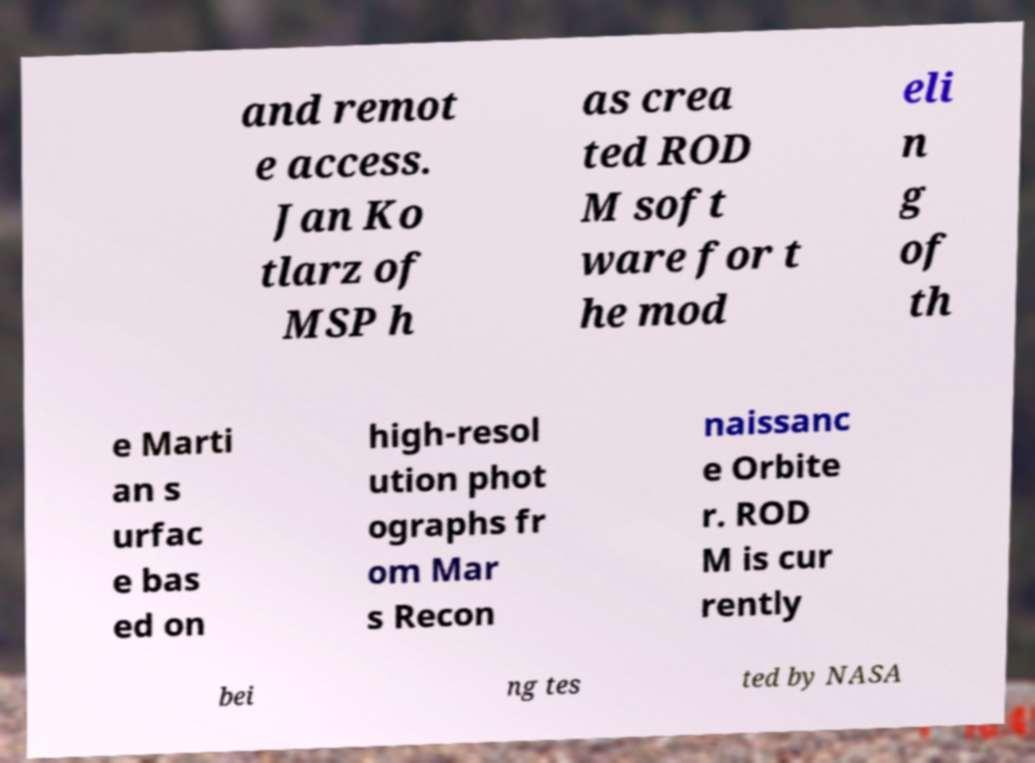There's text embedded in this image that I need extracted. Can you transcribe it verbatim? and remot e access. Jan Ko tlarz of MSP h as crea ted ROD M soft ware for t he mod eli n g of th e Marti an s urfac e bas ed on high-resol ution phot ographs fr om Mar s Recon naissanc e Orbite r. ROD M is cur rently bei ng tes ted by NASA 